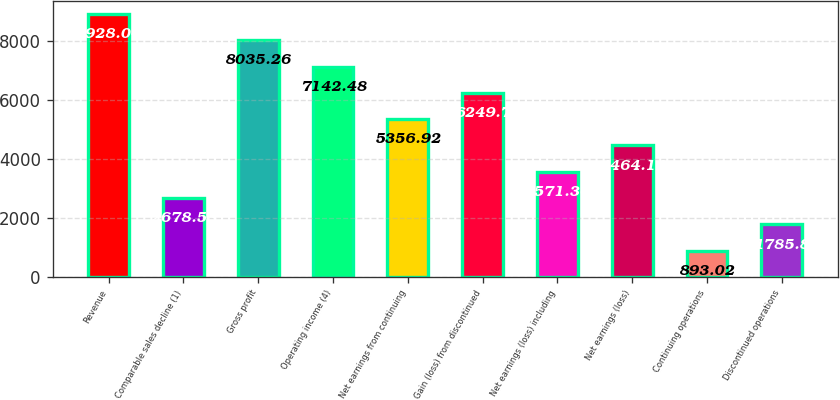Convert chart. <chart><loc_0><loc_0><loc_500><loc_500><bar_chart><fcel>Revenue<fcel>Comparable sales decline (1)<fcel>Gross profit<fcel>Operating income (4)<fcel>Net earnings from continuing<fcel>Gain (loss) from discontinued<fcel>Net earnings (loss) including<fcel>Net earnings (loss)<fcel>Continuing operations<fcel>Discontinued operations<nl><fcel>8928.04<fcel>2678.58<fcel>8035.26<fcel>7142.48<fcel>5356.92<fcel>6249.7<fcel>3571.36<fcel>4464.14<fcel>893.02<fcel>1785.8<nl></chart> 